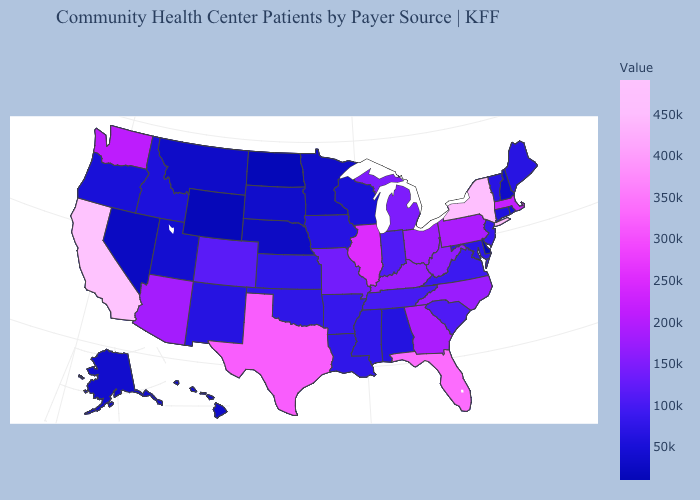Among the states that border Iowa , which have the lowest value?
Short answer required. Nebraska. Which states hav the highest value in the West?
Answer briefly. California. Which states hav the highest value in the West?
Keep it brief. California. Which states have the highest value in the USA?
Write a very short answer. California. Does Virginia have the lowest value in the USA?
Concise answer only. No. Among the states that border Wisconsin , which have the lowest value?
Answer briefly. Minnesota. 